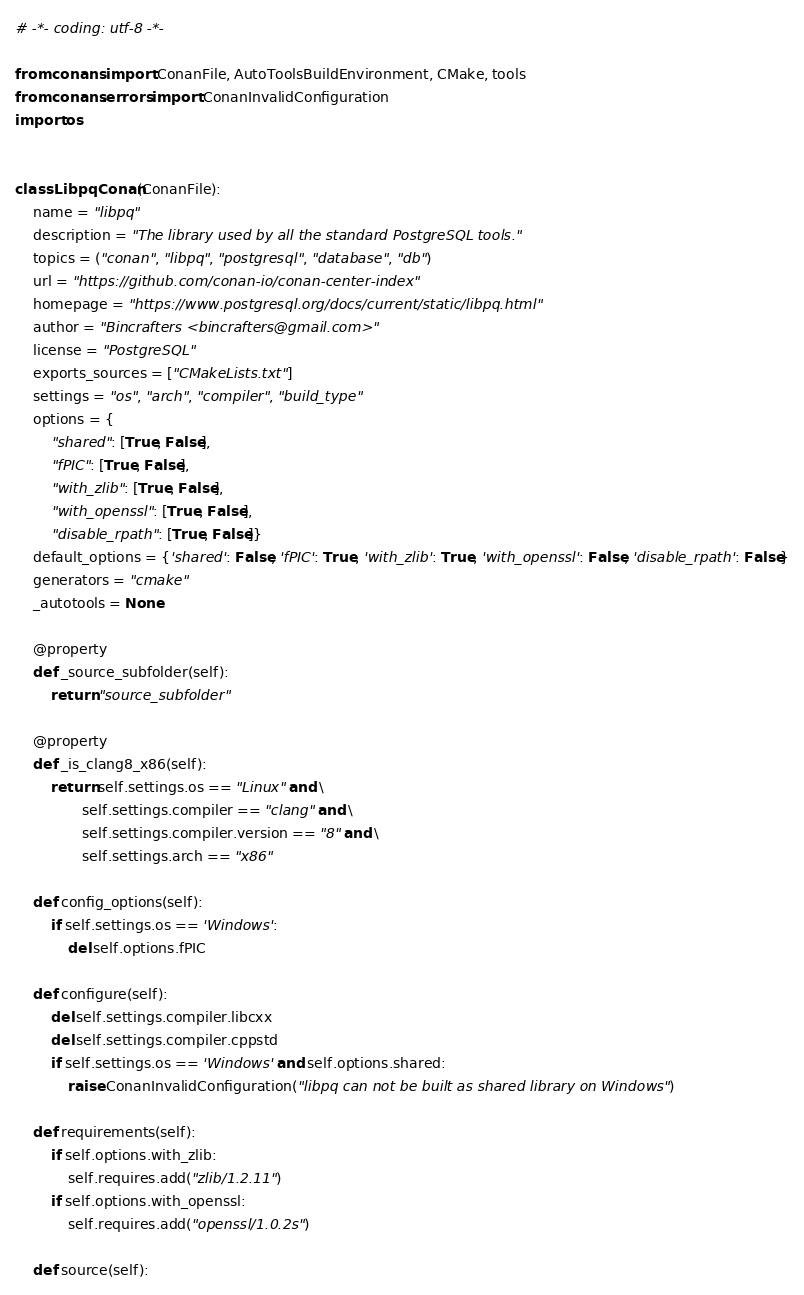Convert code to text. <code><loc_0><loc_0><loc_500><loc_500><_Python_># -*- coding: utf-8 -*-

from conans import ConanFile, AutoToolsBuildEnvironment, CMake, tools
from conans.errors import ConanInvalidConfiguration
import os


class LibpqConan(ConanFile):
    name = "libpq"
    description = "The library used by all the standard PostgreSQL tools."
    topics = ("conan", "libpq", "postgresql", "database", "db")
    url = "https://github.com/conan-io/conan-center-index"
    homepage = "https://www.postgresql.org/docs/current/static/libpq.html"
    author = "Bincrafters <bincrafters@gmail.com>"
    license = "PostgreSQL"
    exports_sources = ["CMakeLists.txt"]
    settings = "os", "arch", "compiler", "build_type"
    options = {
        "shared": [True, False],
        "fPIC": [True, False],
        "with_zlib": [True, False],
        "with_openssl": [True, False],
        "disable_rpath": [True, False]}
    default_options = {'shared': False, 'fPIC': True, 'with_zlib': True, 'with_openssl': False, 'disable_rpath': False}
    generators = "cmake"
    _autotools = None

    @property
    def _source_subfolder(self):
        return "source_subfolder"

    @property
    def _is_clang8_x86(self):
        return self.settings.os == "Linux" and \
               self.settings.compiler == "clang" and \
               self.settings.compiler.version == "8" and \
               self.settings.arch == "x86"

    def config_options(self):
        if self.settings.os == 'Windows':
            del self.options.fPIC

    def configure(self):
        del self.settings.compiler.libcxx
        del self.settings.compiler.cppstd
        if self.settings.os == 'Windows' and self.options.shared:
            raise ConanInvalidConfiguration("libpq can not be built as shared library on Windows")

    def requirements(self):
        if self.options.with_zlib:
            self.requires.add("zlib/1.2.11")
        if self.options.with_openssl:
            self.requires.add("openssl/1.0.2s")

    def source(self):</code> 